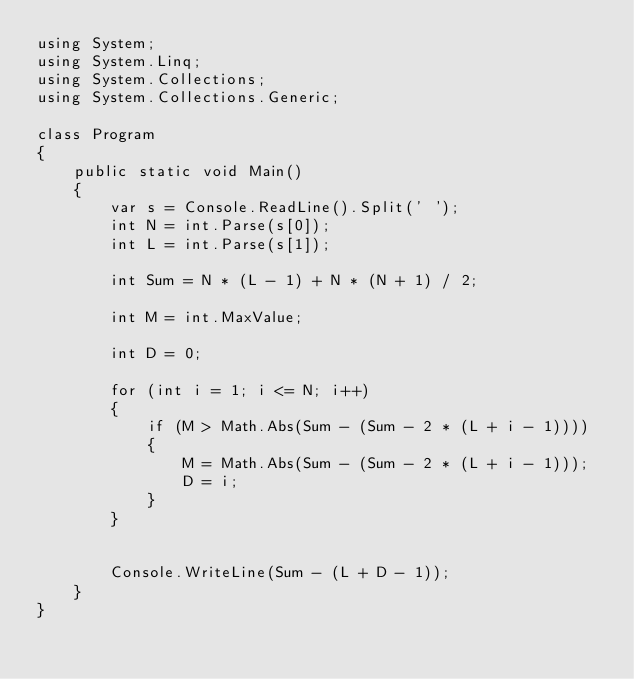<code> <loc_0><loc_0><loc_500><loc_500><_C#_>using System;
using System.Linq;
using System.Collections;
using System.Collections.Generic;

class Program
{
    public static void Main()
    {
        var s = Console.ReadLine().Split(' ');
        int N = int.Parse(s[0]);
        int L = int.Parse(s[1]);

        int Sum = N * (L - 1) + N * (N + 1) / 2;
        
        int M = int.MaxValue;

        int D = 0;

        for (int i = 1; i <= N; i++)
        {
            if (M > Math.Abs(Sum - (Sum - 2 * (L + i - 1))))
            {
                M = Math.Abs(Sum - (Sum - 2 * (L + i - 1)));
                D = i;
            }
        }

                
        Console.WriteLine(Sum - (L + D - 1));                
    }
}</code> 